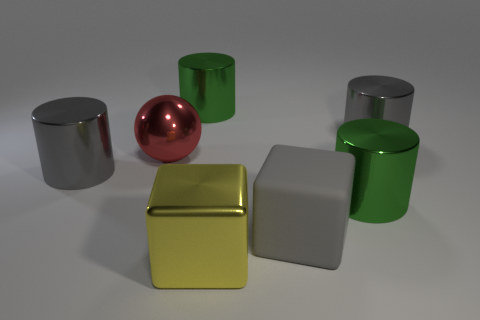Add 2 gray metallic cylinders. How many objects exist? 9 Subtract all gray cubes. How many cubes are left? 1 Subtract 2 cylinders. How many cylinders are left? 2 Subtract 0 green cubes. How many objects are left? 7 Subtract all spheres. How many objects are left? 6 Subtract all gray spheres. Subtract all blue cubes. How many spheres are left? 1 Subtract all gray cubes. How many red cylinders are left? 0 Subtract all red metallic objects. Subtract all purple shiny cubes. How many objects are left? 6 Add 1 metallic objects. How many metallic objects are left? 7 Add 1 spheres. How many spheres exist? 2 